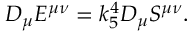Convert formula to latex. <formula><loc_0><loc_0><loc_500><loc_500>D _ { \mu } E ^ { \mu \nu } = k _ { 5 } ^ { 4 } D _ { \mu } S ^ { \mu \nu } .</formula> 